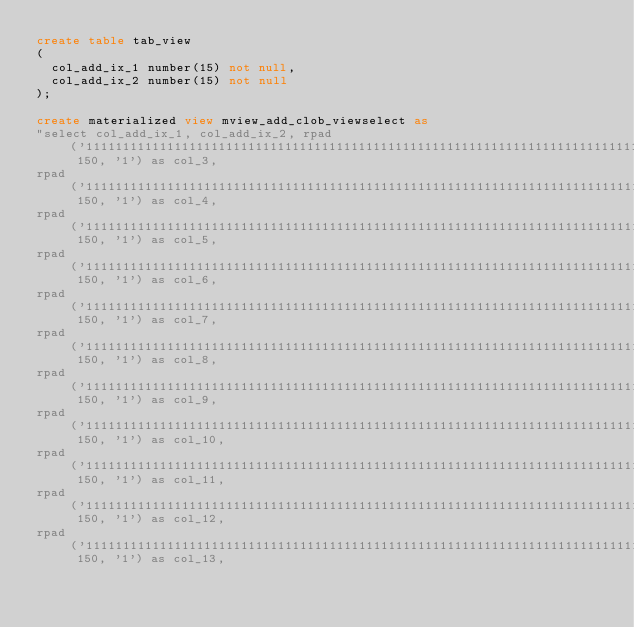<code> <loc_0><loc_0><loc_500><loc_500><_SQL_>create table tab_view
(
  col_add_ix_1 number(15) not null,
  col_add_ix_2 number(15) not null
);

create materialized view mview_add_clob_viewselect as
"select col_add_ix_1, col_add_ix_2, rpad('111111111111111111111111111111111111111111111111111111111111111111111111111111111111111111111111111111111111', 150, '1') as col_3,
rpad('111111111111111111111111111111111111111111111111111111111111111111111111111111111111111111111111111111111111111111111111111111111111111111111111', 150, '1') as col_4,
rpad('111111111111111111111111111111111111111111111111111111111111111111111111111111111111111111111111111111111111111111111111111111111111111111111111', 150, '1') as col_5,
rpad('111111111111111111111111111111111111111111111111111111111111111111111111111111111111111111111111111111111111111111111111111111111111111111111111', 150, '1') as col_6,
rpad('111111111111111111111111111111111111111111111111111111111111111111111111111111111111111111111111111111111111111111111111111111111111111111111111', 150, '1') as col_7,
rpad('111111111111111111111111111111111111111111111111111111111111111111111111111111111111111111111111111111111111111111111111111111111111111111111111', 150, '1') as col_8,
rpad('111111111111111111111111111111111111111111111111111111111111111111111111111111111111111111111111111111111111111111111111111111111111111111111111', 150, '1') as col_9,
rpad('111111111111111111111111111111111111111111111111111111111111111111111111111111111111111111111111111111111111111111111111111111111111111111111111', 150, '1') as col_10,
rpad('111111111111111111111111111111111111111111111111111111111111111111111111111111111111111111111111111111111111111111111111111111111111111111111111', 150, '1') as col_11,
rpad('111111111111111111111111111111111111111111111111111111111111111111111111111111111111111111111111111111111111111111111111111111111111111111111111', 150, '1') as col_12,
rpad('111111111111111111111111111111111111111111111111111111111111111111111111111111111111111111111111111111111111111111111111111111111111111111111111', 150, '1') as col_13,</code> 